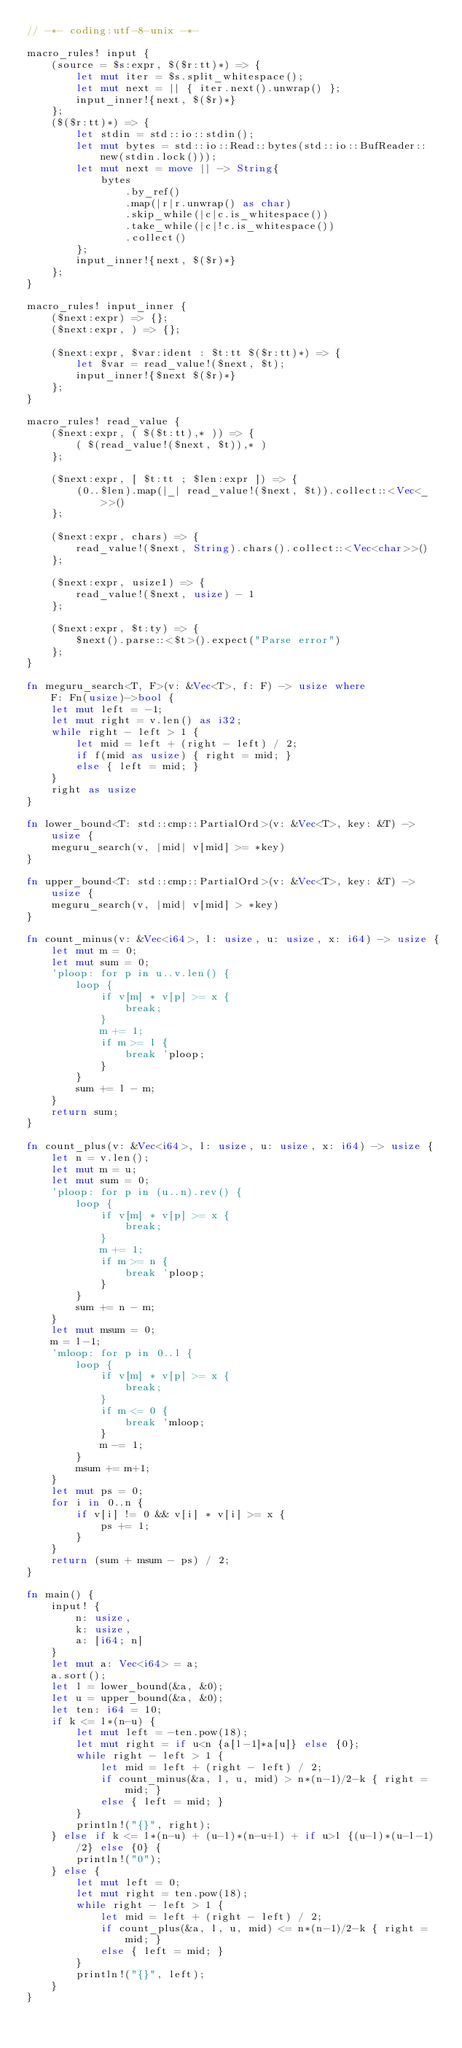<code> <loc_0><loc_0><loc_500><loc_500><_Rust_>// -*- coding:utf-8-unix -*-

macro_rules! input {
    (source = $s:expr, $($r:tt)*) => {
        let mut iter = $s.split_whitespace();
        let mut next = || { iter.next().unwrap() };
        input_inner!{next, $($r)*}
    };
    ($($r:tt)*) => {
        let stdin = std::io::stdin();
        let mut bytes = std::io::Read::bytes(std::io::BufReader::new(stdin.lock()));
        let mut next = move || -> String{
            bytes
                .by_ref()
                .map(|r|r.unwrap() as char)
                .skip_while(|c|c.is_whitespace())
                .take_while(|c|!c.is_whitespace())
                .collect()
        };
        input_inner!{next, $($r)*}
    };
}

macro_rules! input_inner {
    ($next:expr) => {};
    ($next:expr, ) => {};

    ($next:expr, $var:ident : $t:tt $($r:tt)*) => {
        let $var = read_value!($next, $t);
        input_inner!{$next $($r)*}
    };
}

macro_rules! read_value {
    ($next:expr, ( $($t:tt),* )) => {
        ( $(read_value!($next, $t)),* )
    };

    ($next:expr, [ $t:tt ; $len:expr ]) => {
        (0..$len).map(|_| read_value!($next, $t)).collect::<Vec<_>>()
    };

    ($next:expr, chars) => {
        read_value!($next, String).chars().collect::<Vec<char>>()
    };

    ($next:expr, usize1) => {
        read_value!($next, usize) - 1
    };

    ($next:expr, $t:ty) => {
        $next().parse::<$t>().expect("Parse error")
    };
}

fn meguru_search<T, F>(v: &Vec<T>, f: F) -> usize where
    F: Fn(usize)->bool {
    let mut left = -1;
    let mut right = v.len() as i32;
    while right - left > 1 {
        let mid = left + (right - left) / 2;
        if f(mid as usize) { right = mid; }
        else { left = mid; }
    }
    right as usize
}

fn lower_bound<T: std::cmp::PartialOrd>(v: &Vec<T>, key: &T) -> usize {
    meguru_search(v, |mid| v[mid] >= *key)
}

fn upper_bound<T: std::cmp::PartialOrd>(v: &Vec<T>, key: &T) -> usize {
    meguru_search(v, |mid| v[mid] > *key)
}

fn count_minus(v: &Vec<i64>, l: usize, u: usize, x: i64) -> usize {
    let mut m = 0;
    let mut sum = 0;
    'ploop: for p in u..v.len() {
        loop {
            if v[m] * v[p] >= x {
                break;
            }
            m += 1;
            if m >= l {
                break 'ploop;
            }
        }
        sum += l - m;
    }
    return sum;
}

fn count_plus(v: &Vec<i64>, l: usize, u: usize, x: i64) -> usize {
    let n = v.len();
    let mut m = u;
    let mut sum = 0;
    'ploop: for p in (u..n).rev() {
        loop {
            if v[m] * v[p] >= x {
                break;
            }
            m += 1;
            if m >= n {
                break 'ploop;
            }
        }
        sum += n - m;
    }
    let mut msum = 0;
    m = l-1;
    'mloop: for p in 0..l {
        loop {
            if v[m] * v[p] >= x {
                break;
            }
            if m <= 0 {
                break 'mloop;
            }
            m -= 1;
        }
        msum += m+1;
    }
    let mut ps = 0;
    for i in 0..n {
        if v[i] != 0 && v[i] * v[i] >= x {
            ps += 1;
        }
    }
    return (sum + msum - ps) / 2;
}

fn main() {
    input! {
        n: usize,
        k: usize,
        a: [i64; n]
    }
    let mut a: Vec<i64> = a;
    a.sort();
    let l = lower_bound(&a, &0);
    let u = upper_bound(&a, &0);
    let ten: i64 = 10;
    if k <= l*(n-u) {
        let mut left = -ten.pow(18);
        let mut right = if u<n {a[l-1]*a[u]} else {0};
        while right - left > 1 {
            let mid = left + (right - left) / 2;
            if count_minus(&a, l, u, mid) > n*(n-1)/2-k { right = mid; }
            else { left = mid; }
        }
        println!("{}", right);
    } else if k <= l*(n-u) + (u-l)*(n-u+l) + if u>l {(u-l)*(u-l-1)/2} else {0} {
        println!("0");
    } else {
        let mut left = 0;
        let mut right = ten.pow(18);
        while right - left > 1 {
            let mid = left + (right - left) / 2;
            if count_plus(&a, l, u, mid) <= n*(n-1)/2-k { right = mid; }
            else { left = mid; }
        }
        println!("{}", left);
    }
}</code> 